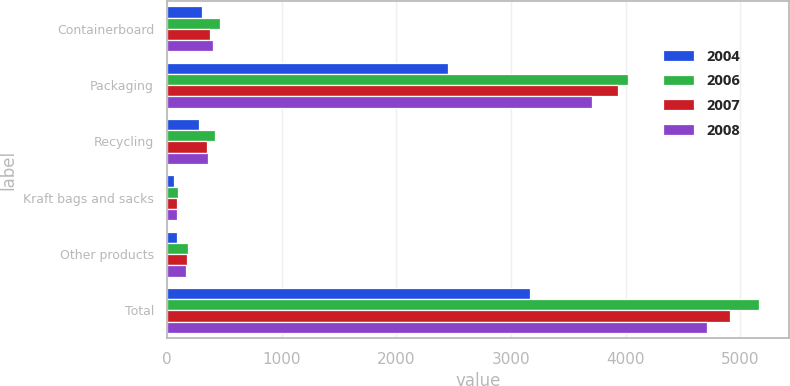Convert chart. <chart><loc_0><loc_0><loc_500><loc_500><stacked_bar_chart><ecel><fcel>Containerboard<fcel>Packaging<fcel>Recycling<fcel>Kraft bags and sacks<fcel>Other products<fcel>Total<nl><fcel>2004<fcel>301<fcel>2449<fcel>275<fcel>56<fcel>88<fcel>3169<nl><fcel>2006<fcel>457<fcel>4019<fcel>413<fcel>96<fcel>183<fcel>5168<nl><fcel>2007<fcel>377<fcel>3931<fcel>345<fcel>88<fcel>171<fcel>4912<nl><fcel>2008<fcel>395<fcel>3710<fcel>352<fcel>83<fcel>167<fcel>4707<nl></chart> 